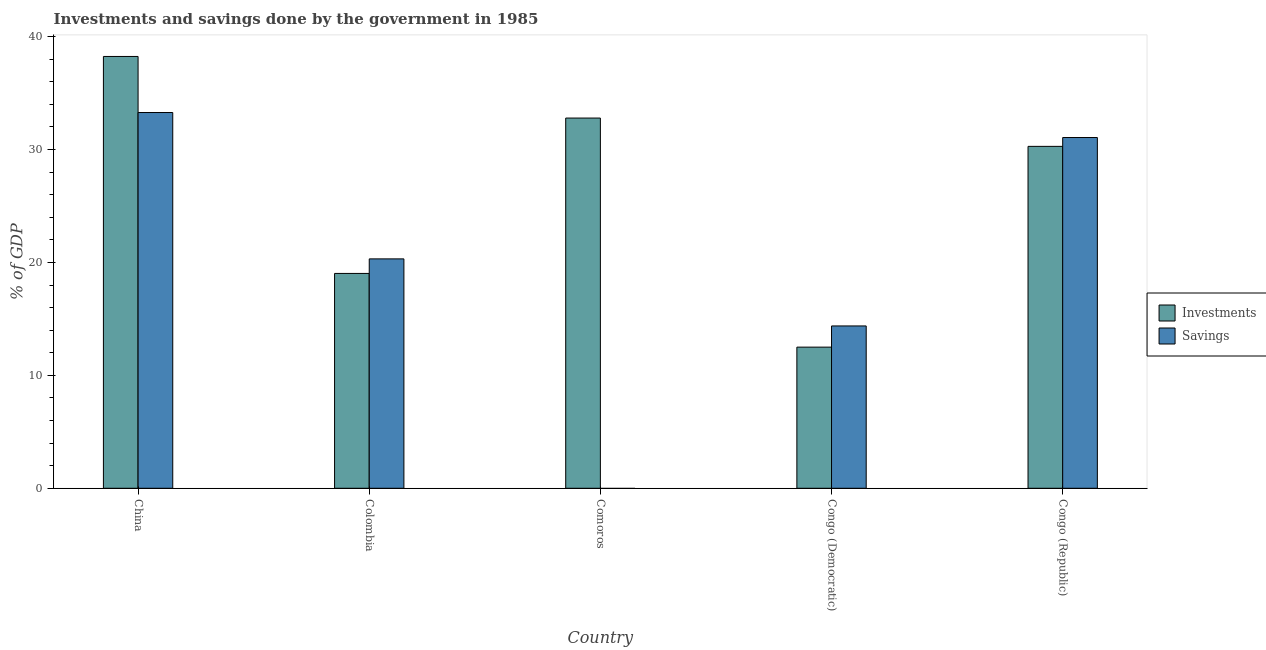How many different coloured bars are there?
Make the answer very short. 2. Are the number of bars per tick equal to the number of legend labels?
Provide a short and direct response. No. Are the number of bars on each tick of the X-axis equal?
Your answer should be very brief. No. How many bars are there on the 1st tick from the right?
Offer a very short reply. 2. What is the investments of government in Congo (Democratic)?
Your answer should be compact. 12.5. Across all countries, what is the maximum investments of government?
Offer a terse response. 38.25. Across all countries, what is the minimum investments of government?
Your answer should be very brief. 12.5. What is the total investments of government in the graph?
Keep it short and to the point. 132.86. What is the difference between the investments of government in Comoros and that in Congo (Republic)?
Your answer should be very brief. 2.51. What is the difference between the investments of government in Comoros and the savings of government in Colombia?
Provide a succinct answer. 12.47. What is the average investments of government per country?
Give a very brief answer. 26.57. What is the difference between the savings of government and investments of government in China?
Ensure brevity in your answer.  -4.97. In how many countries, is the savings of government greater than 38 %?
Offer a terse response. 0. What is the ratio of the investments of government in Congo (Democratic) to that in Congo (Republic)?
Your answer should be very brief. 0.41. Is the savings of government in China less than that in Congo (Republic)?
Your answer should be compact. No. Is the difference between the savings of government in Colombia and Congo (Democratic) greater than the difference between the investments of government in Colombia and Congo (Democratic)?
Offer a very short reply. No. What is the difference between the highest and the second highest savings of government?
Offer a terse response. 2.21. What is the difference between the highest and the lowest savings of government?
Ensure brevity in your answer.  33.28. In how many countries, is the investments of government greater than the average investments of government taken over all countries?
Your response must be concise. 3. Is the sum of the savings of government in Congo (Democratic) and Congo (Republic) greater than the maximum investments of government across all countries?
Your answer should be very brief. Yes. How many bars are there?
Offer a terse response. 9. What is the difference between two consecutive major ticks on the Y-axis?
Ensure brevity in your answer.  10. Does the graph contain any zero values?
Your response must be concise. Yes. What is the title of the graph?
Make the answer very short. Investments and savings done by the government in 1985. Does "National Tourists" appear as one of the legend labels in the graph?
Offer a terse response. No. What is the label or title of the X-axis?
Your answer should be very brief. Country. What is the label or title of the Y-axis?
Your answer should be compact. % of GDP. What is the % of GDP in Investments in China?
Your answer should be compact. 38.25. What is the % of GDP of Savings in China?
Ensure brevity in your answer.  33.28. What is the % of GDP in Investments in Colombia?
Your answer should be very brief. 19.03. What is the % of GDP in Savings in Colombia?
Provide a succinct answer. 20.32. What is the % of GDP of Investments in Comoros?
Your response must be concise. 32.79. What is the % of GDP of Savings in Comoros?
Your answer should be very brief. 0. What is the % of GDP in Investments in Congo (Democratic)?
Make the answer very short. 12.5. What is the % of GDP of Savings in Congo (Democratic)?
Your response must be concise. 14.38. What is the % of GDP in Investments in Congo (Republic)?
Offer a very short reply. 30.28. What is the % of GDP of Savings in Congo (Republic)?
Offer a very short reply. 31.07. Across all countries, what is the maximum % of GDP in Investments?
Offer a terse response. 38.25. Across all countries, what is the maximum % of GDP in Savings?
Offer a terse response. 33.28. Across all countries, what is the minimum % of GDP of Investments?
Your answer should be compact. 12.5. What is the total % of GDP in Investments in the graph?
Offer a very short reply. 132.86. What is the total % of GDP in Savings in the graph?
Your answer should be very brief. 99.05. What is the difference between the % of GDP of Investments in China and that in Colombia?
Your answer should be very brief. 19.22. What is the difference between the % of GDP in Savings in China and that in Colombia?
Provide a short and direct response. 12.96. What is the difference between the % of GDP in Investments in China and that in Comoros?
Ensure brevity in your answer.  5.45. What is the difference between the % of GDP in Investments in China and that in Congo (Democratic)?
Your response must be concise. 25.74. What is the difference between the % of GDP in Savings in China and that in Congo (Democratic)?
Provide a short and direct response. 18.9. What is the difference between the % of GDP of Investments in China and that in Congo (Republic)?
Your answer should be compact. 7.96. What is the difference between the % of GDP in Savings in China and that in Congo (Republic)?
Ensure brevity in your answer.  2.21. What is the difference between the % of GDP in Investments in Colombia and that in Comoros?
Make the answer very short. -13.76. What is the difference between the % of GDP in Investments in Colombia and that in Congo (Democratic)?
Give a very brief answer. 6.53. What is the difference between the % of GDP in Savings in Colombia and that in Congo (Democratic)?
Offer a very short reply. 5.94. What is the difference between the % of GDP of Investments in Colombia and that in Congo (Republic)?
Give a very brief answer. -11.25. What is the difference between the % of GDP in Savings in Colombia and that in Congo (Republic)?
Provide a succinct answer. -10.75. What is the difference between the % of GDP of Investments in Comoros and that in Congo (Democratic)?
Keep it short and to the point. 20.29. What is the difference between the % of GDP in Investments in Comoros and that in Congo (Republic)?
Make the answer very short. 2.51. What is the difference between the % of GDP in Investments in Congo (Democratic) and that in Congo (Republic)?
Keep it short and to the point. -17.78. What is the difference between the % of GDP in Savings in Congo (Democratic) and that in Congo (Republic)?
Your answer should be compact. -16.69. What is the difference between the % of GDP in Investments in China and the % of GDP in Savings in Colombia?
Your answer should be very brief. 17.93. What is the difference between the % of GDP of Investments in China and the % of GDP of Savings in Congo (Democratic)?
Ensure brevity in your answer.  23.87. What is the difference between the % of GDP of Investments in China and the % of GDP of Savings in Congo (Republic)?
Offer a very short reply. 7.18. What is the difference between the % of GDP of Investments in Colombia and the % of GDP of Savings in Congo (Democratic)?
Provide a short and direct response. 4.65. What is the difference between the % of GDP of Investments in Colombia and the % of GDP of Savings in Congo (Republic)?
Give a very brief answer. -12.04. What is the difference between the % of GDP of Investments in Comoros and the % of GDP of Savings in Congo (Democratic)?
Keep it short and to the point. 18.41. What is the difference between the % of GDP of Investments in Comoros and the % of GDP of Savings in Congo (Republic)?
Offer a terse response. 1.73. What is the difference between the % of GDP of Investments in Congo (Democratic) and the % of GDP of Savings in Congo (Republic)?
Offer a very short reply. -18.57. What is the average % of GDP in Investments per country?
Your answer should be compact. 26.57. What is the average % of GDP in Savings per country?
Provide a short and direct response. 19.81. What is the difference between the % of GDP of Investments and % of GDP of Savings in China?
Ensure brevity in your answer.  4.97. What is the difference between the % of GDP of Investments and % of GDP of Savings in Colombia?
Make the answer very short. -1.29. What is the difference between the % of GDP in Investments and % of GDP in Savings in Congo (Democratic)?
Your answer should be compact. -1.88. What is the difference between the % of GDP of Investments and % of GDP of Savings in Congo (Republic)?
Make the answer very short. -0.78. What is the ratio of the % of GDP of Investments in China to that in Colombia?
Provide a succinct answer. 2.01. What is the ratio of the % of GDP of Savings in China to that in Colombia?
Offer a very short reply. 1.64. What is the ratio of the % of GDP in Investments in China to that in Comoros?
Give a very brief answer. 1.17. What is the ratio of the % of GDP of Investments in China to that in Congo (Democratic)?
Provide a succinct answer. 3.06. What is the ratio of the % of GDP in Savings in China to that in Congo (Democratic)?
Provide a short and direct response. 2.31. What is the ratio of the % of GDP of Investments in China to that in Congo (Republic)?
Provide a succinct answer. 1.26. What is the ratio of the % of GDP in Savings in China to that in Congo (Republic)?
Make the answer very short. 1.07. What is the ratio of the % of GDP of Investments in Colombia to that in Comoros?
Keep it short and to the point. 0.58. What is the ratio of the % of GDP of Investments in Colombia to that in Congo (Democratic)?
Ensure brevity in your answer.  1.52. What is the ratio of the % of GDP in Savings in Colombia to that in Congo (Democratic)?
Provide a succinct answer. 1.41. What is the ratio of the % of GDP in Investments in Colombia to that in Congo (Republic)?
Give a very brief answer. 0.63. What is the ratio of the % of GDP in Savings in Colombia to that in Congo (Republic)?
Provide a succinct answer. 0.65. What is the ratio of the % of GDP in Investments in Comoros to that in Congo (Democratic)?
Give a very brief answer. 2.62. What is the ratio of the % of GDP of Investments in Comoros to that in Congo (Republic)?
Your answer should be very brief. 1.08. What is the ratio of the % of GDP in Investments in Congo (Democratic) to that in Congo (Republic)?
Your answer should be very brief. 0.41. What is the ratio of the % of GDP of Savings in Congo (Democratic) to that in Congo (Republic)?
Keep it short and to the point. 0.46. What is the difference between the highest and the second highest % of GDP in Investments?
Ensure brevity in your answer.  5.45. What is the difference between the highest and the second highest % of GDP of Savings?
Offer a very short reply. 2.21. What is the difference between the highest and the lowest % of GDP in Investments?
Provide a succinct answer. 25.74. What is the difference between the highest and the lowest % of GDP of Savings?
Provide a succinct answer. 33.28. 